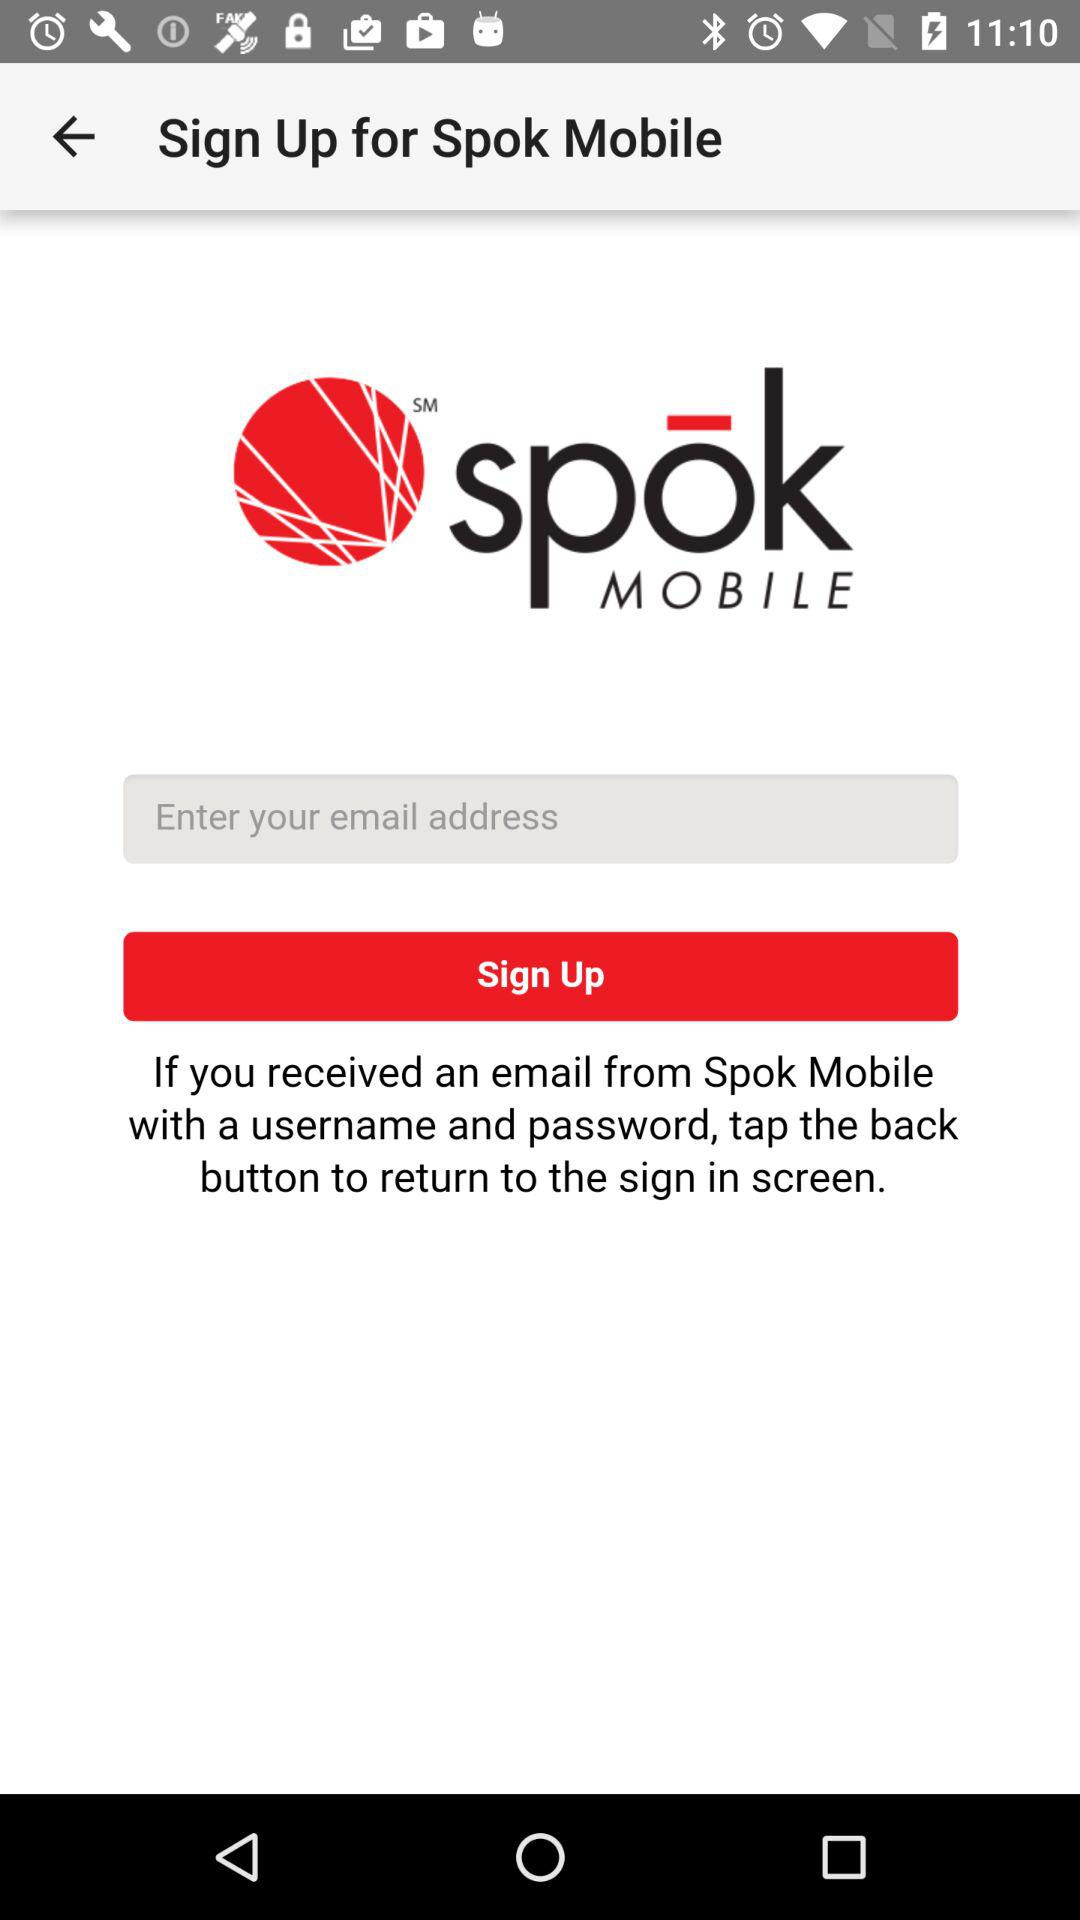What is the name of the application? The name of the application is "Spok Mobile". 